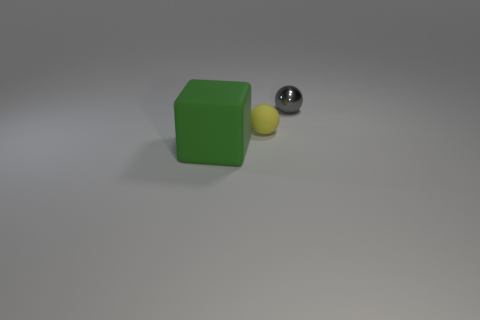Add 2 gray metal things. How many objects exist? 5 Subtract 0 red balls. How many objects are left? 3 Subtract all blocks. How many objects are left? 2 Subtract 1 blocks. How many blocks are left? 0 Subtract all cyan cubes. Subtract all red balls. How many cubes are left? 1 Subtract all red cylinders. How many cyan balls are left? 0 Subtract all tiny cyan shiny cubes. Subtract all gray shiny objects. How many objects are left? 2 Add 3 gray spheres. How many gray spheres are left? 4 Add 2 small gray balls. How many small gray balls exist? 3 